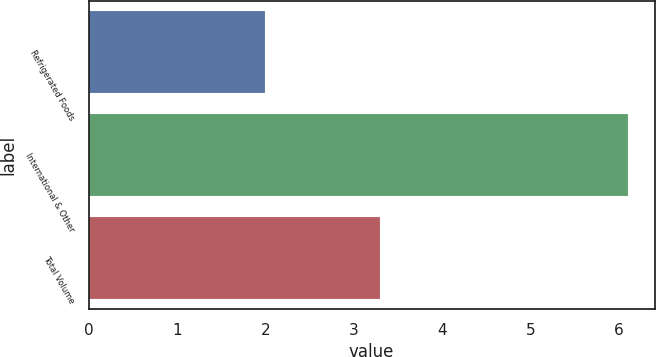Convert chart. <chart><loc_0><loc_0><loc_500><loc_500><bar_chart><fcel>Refrigerated Foods<fcel>International & Other<fcel>Total Volume<nl><fcel>2<fcel>6.1<fcel>3.3<nl></chart> 